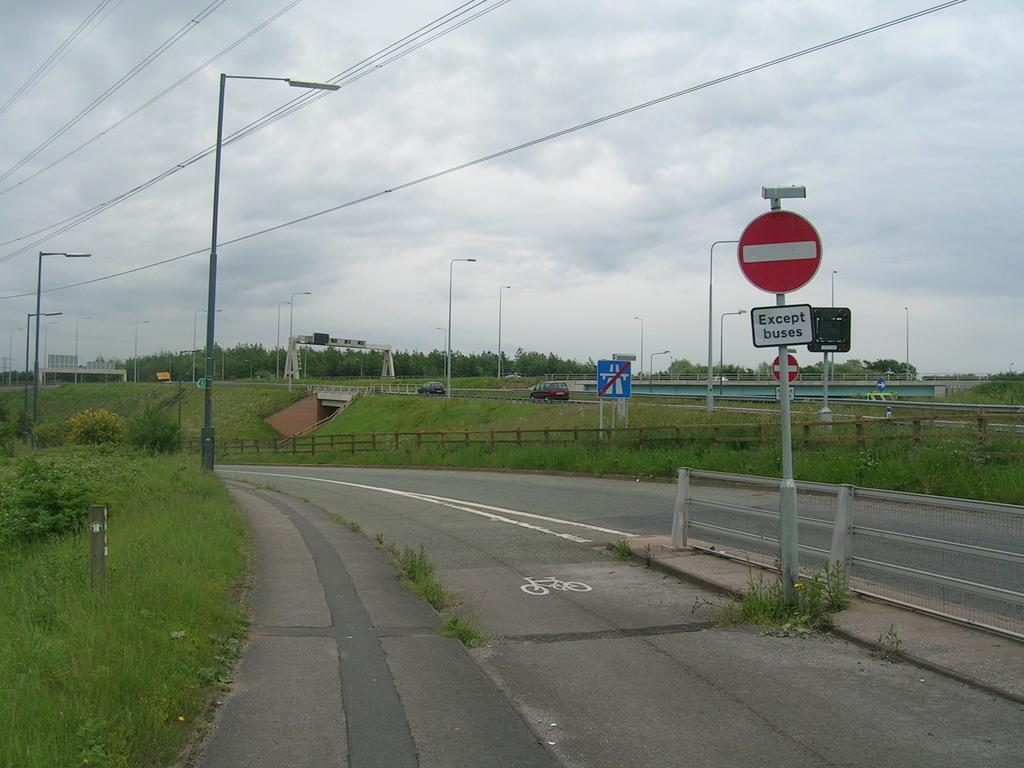<image>
Describe the image concisely. A do not enter road sign is just above another sign that says except buses, in between the bike lane and the road. 